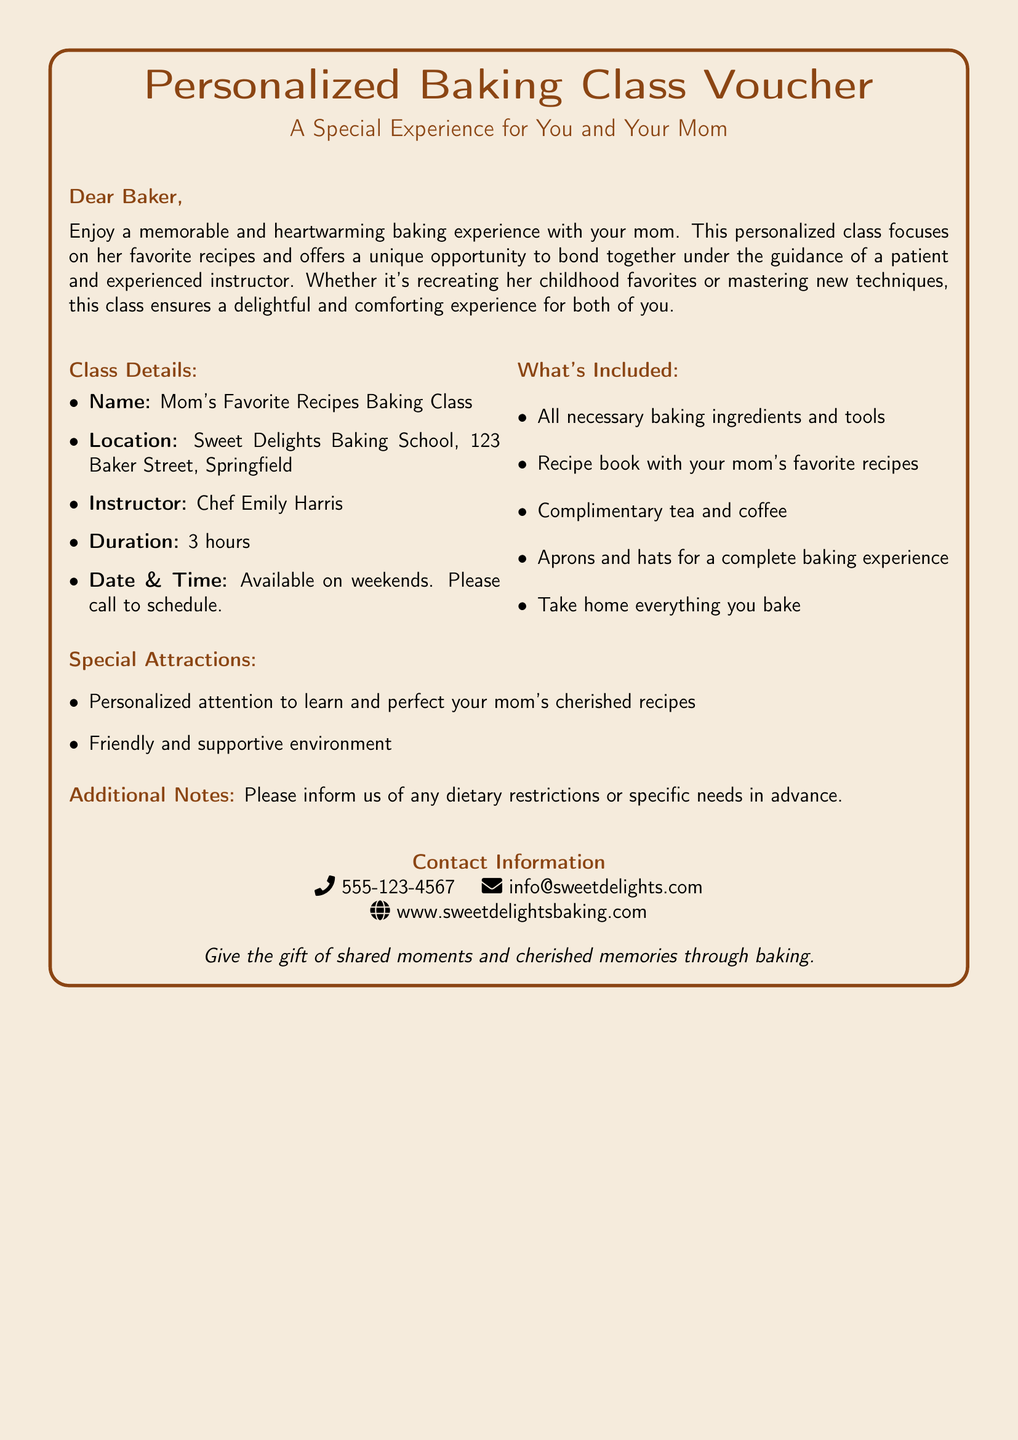What is the class name? The class name is explicitly mentioned in the document under "Class Details."
Answer: Mom's Favorite Recipes Baking Class Who is the instructor's name? The instructor's name is listed in the "Class Details" section.
Answer: Chef Emily Harris What is the duration of the baking class? The duration is specified in the "Class Details" section of the document.
Answer: 3 hours Where is the baking class located? The location is mentioned in the "Class Details."
Answer: Sweet Delights Baking School, 123 Baker Street, Springfield What is included in the class? The items included are detailed in the "What's Included" section.
Answer: All necessary baking ingredients and tools What type of environment will the class provide? This detail is mentioned in the "Special Attractions" section regarding the class atmosphere.
Answer: Friendly and supportive environment What should you inform in advance? The document mentions this under "Additional Notes."
Answer: Dietary restrictions or specific needs When are the classes available? The availability of classes is noted in the "Class Details" section.
Answer: On weekends 